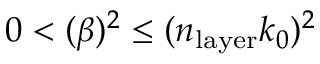Convert formula to latex. <formula><loc_0><loc_0><loc_500><loc_500>0 < ( \beta ) ^ { 2 } \leq ( n _ { l a y e r } k _ { 0 } ) ^ { 2 }</formula> 